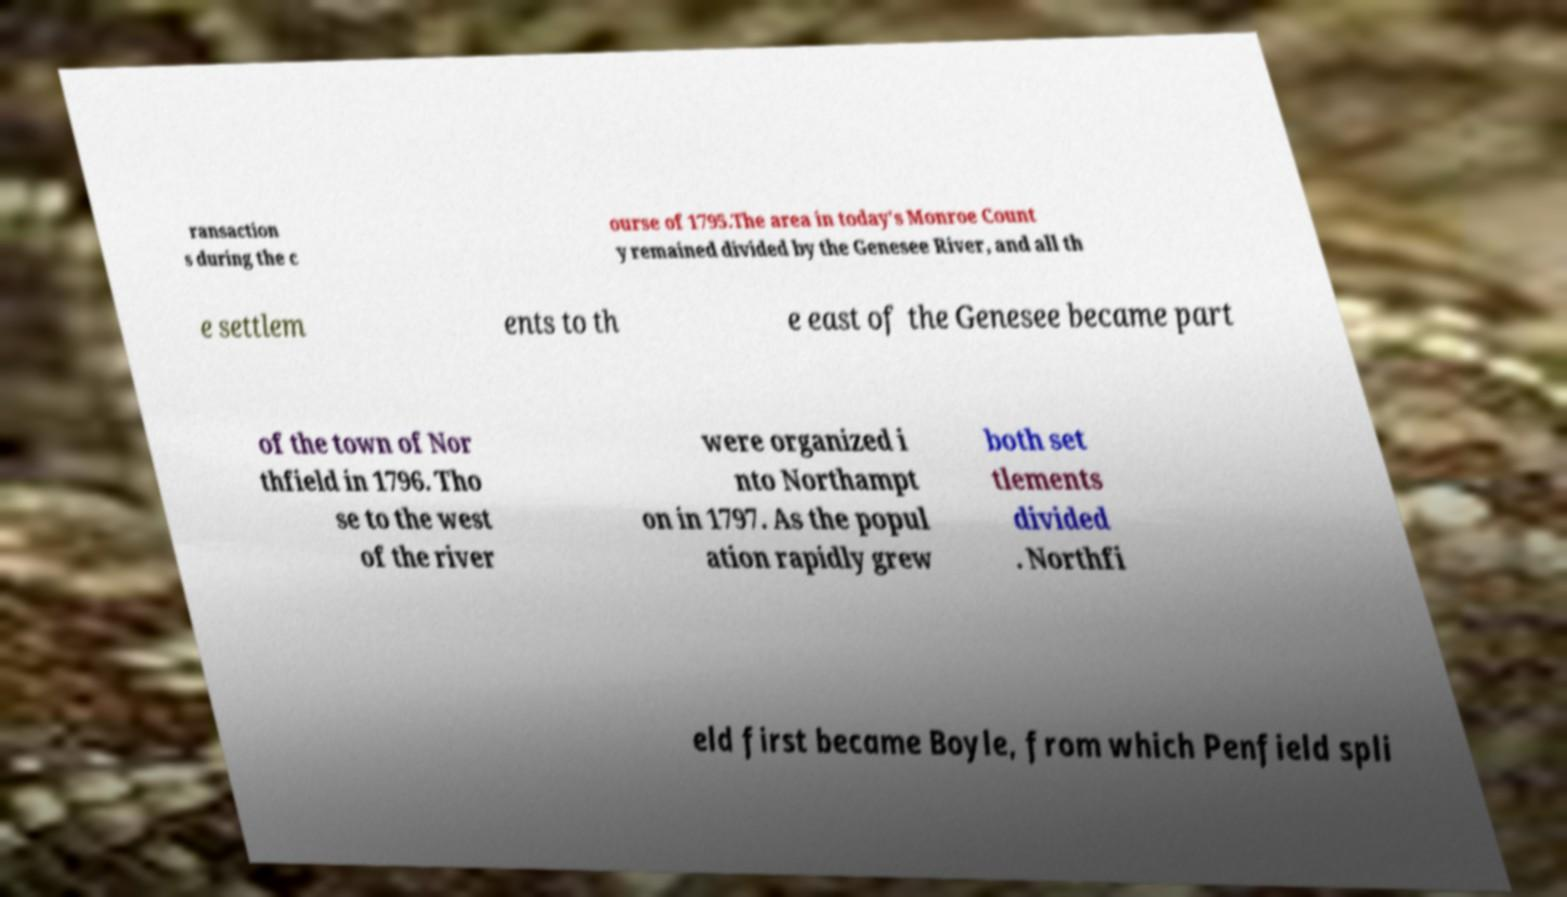I need the written content from this picture converted into text. Can you do that? ransaction s during the c ourse of 1795.The area in today's Monroe Count y remained divided by the Genesee River, and all th e settlem ents to th e east of the Genesee became part of the town of Nor thfield in 1796. Tho se to the west of the river were organized i nto Northampt on in 1797. As the popul ation rapidly grew both set tlements divided . Northfi eld first became Boyle, from which Penfield spli 